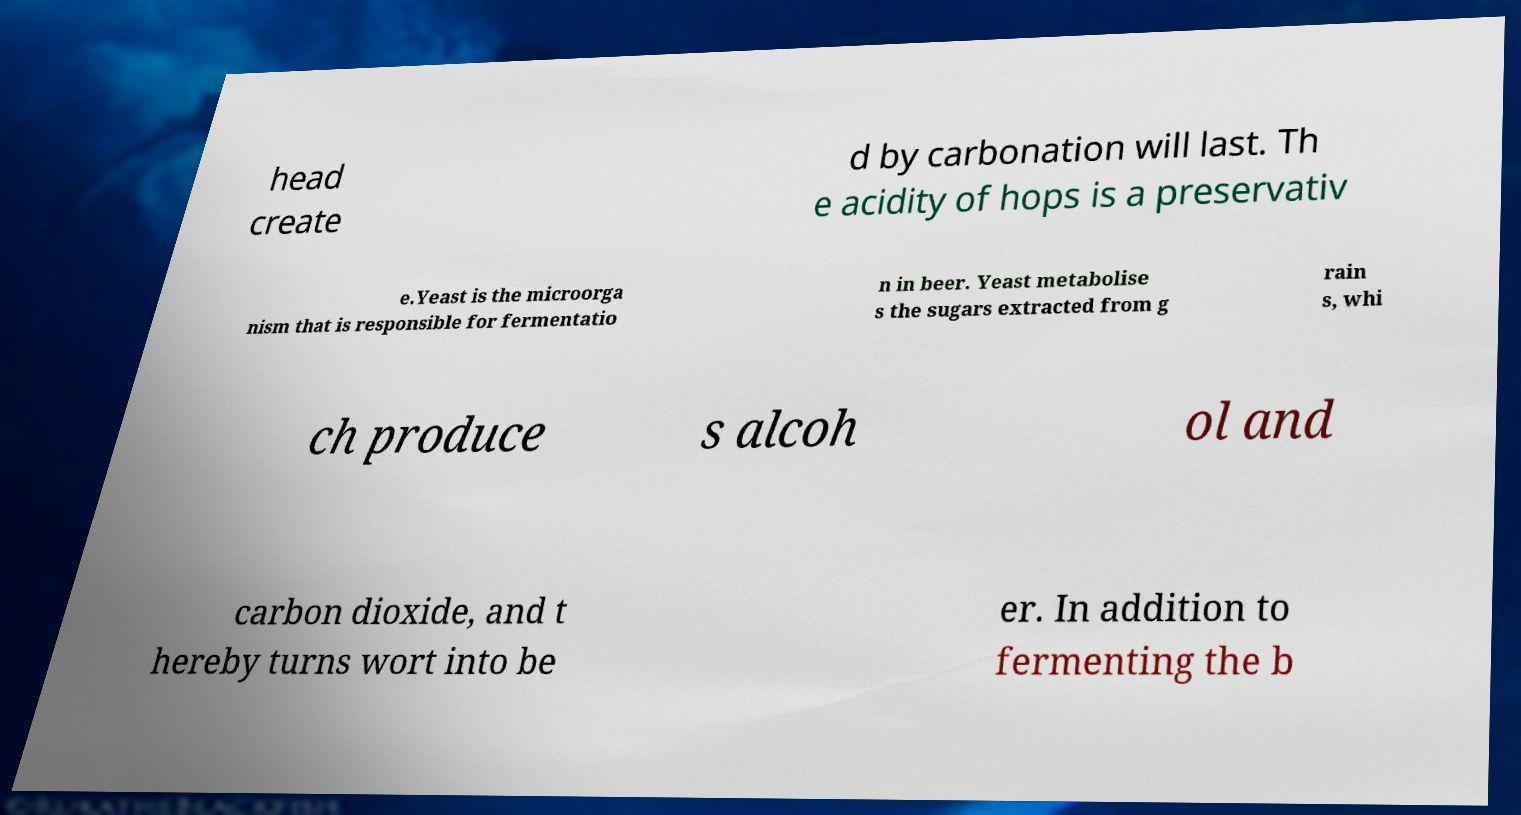There's text embedded in this image that I need extracted. Can you transcribe it verbatim? head create d by carbonation will last. Th e acidity of hops is a preservativ e.Yeast is the microorga nism that is responsible for fermentatio n in beer. Yeast metabolise s the sugars extracted from g rain s, whi ch produce s alcoh ol and carbon dioxide, and t hereby turns wort into be er. In addition to fermenting the b 